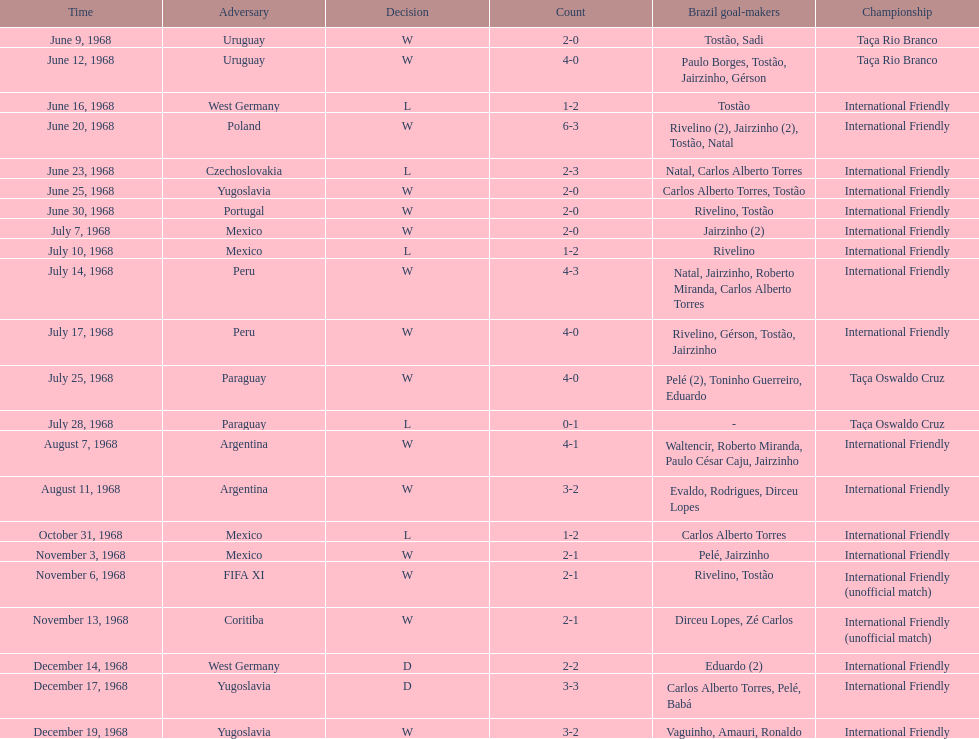How many matches are wins? 15. 